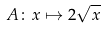Convert formula to latex. <formula><loc_0><loc_0><loc_500><loc_500>A \colon x \mapsto 2 \sqrt { x }</formula> 